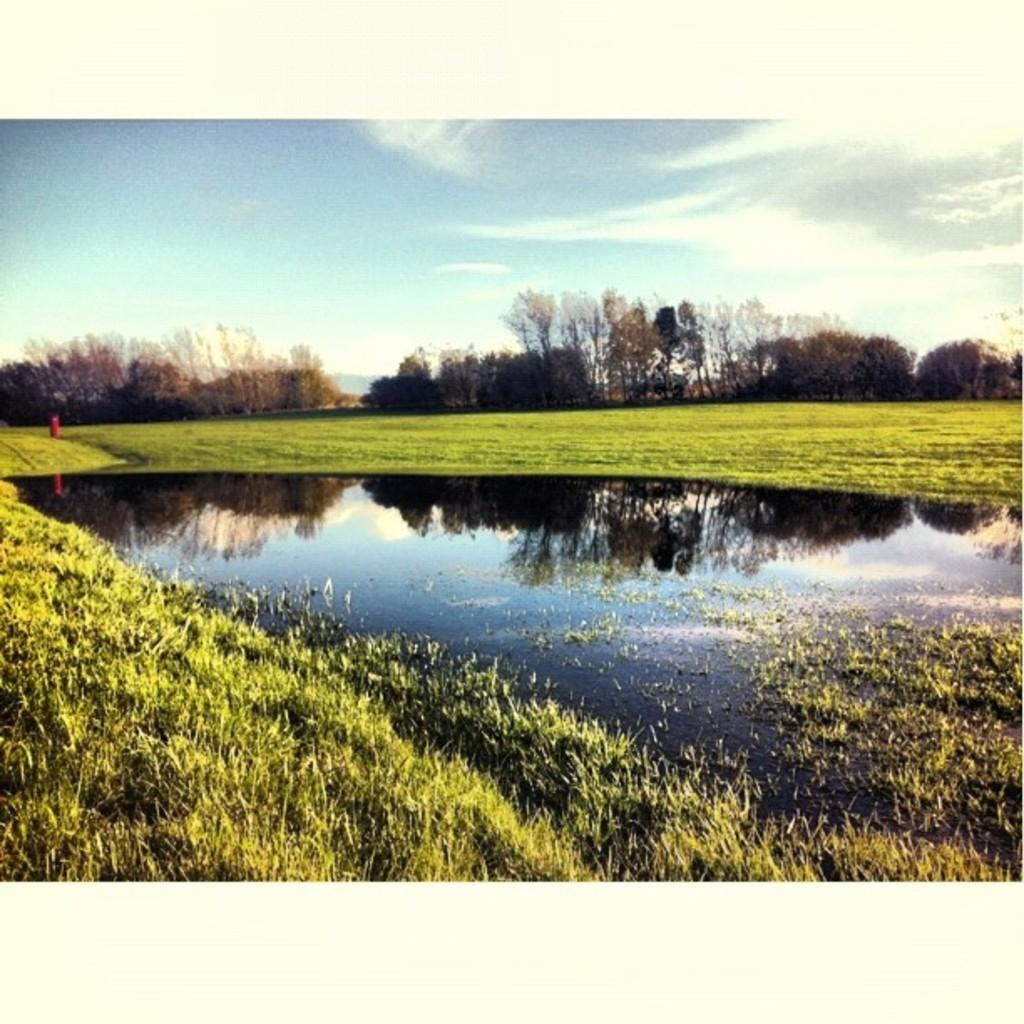What is located in the middle of the image? There is water in the middle of the image. What type of vegetation can be seen at the backside of the image? There are trees at the backside of the image. What is visible at the top of the image? The sky is visible at the top of the image. What type of joke can be seen hanging from the trees in the image? There is no joke present in the image; it features water, trees, and the sky. Can you describe the bun that is floating on the water in the image? There is no bun present in the image; it only features water, trees, and the sky. 